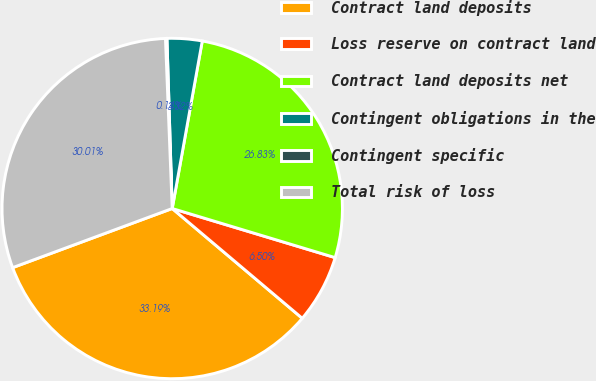<chart> <loc_0><loc_0><loc_500><loc_500><pie_chart><fcel>Contract land deposits<fcel>Loss reserve on contract land<fcel>Contract land deposits net<fcel>Contingent obligations in the<fcel>Contingent specific<fcel>Total risk of loss<nl><fcel>33.2%<fcel>6.5%<fcel>26.84%<fcel>3.32%<fcel>0.14%<fcel>30.02%<nl></chart> 